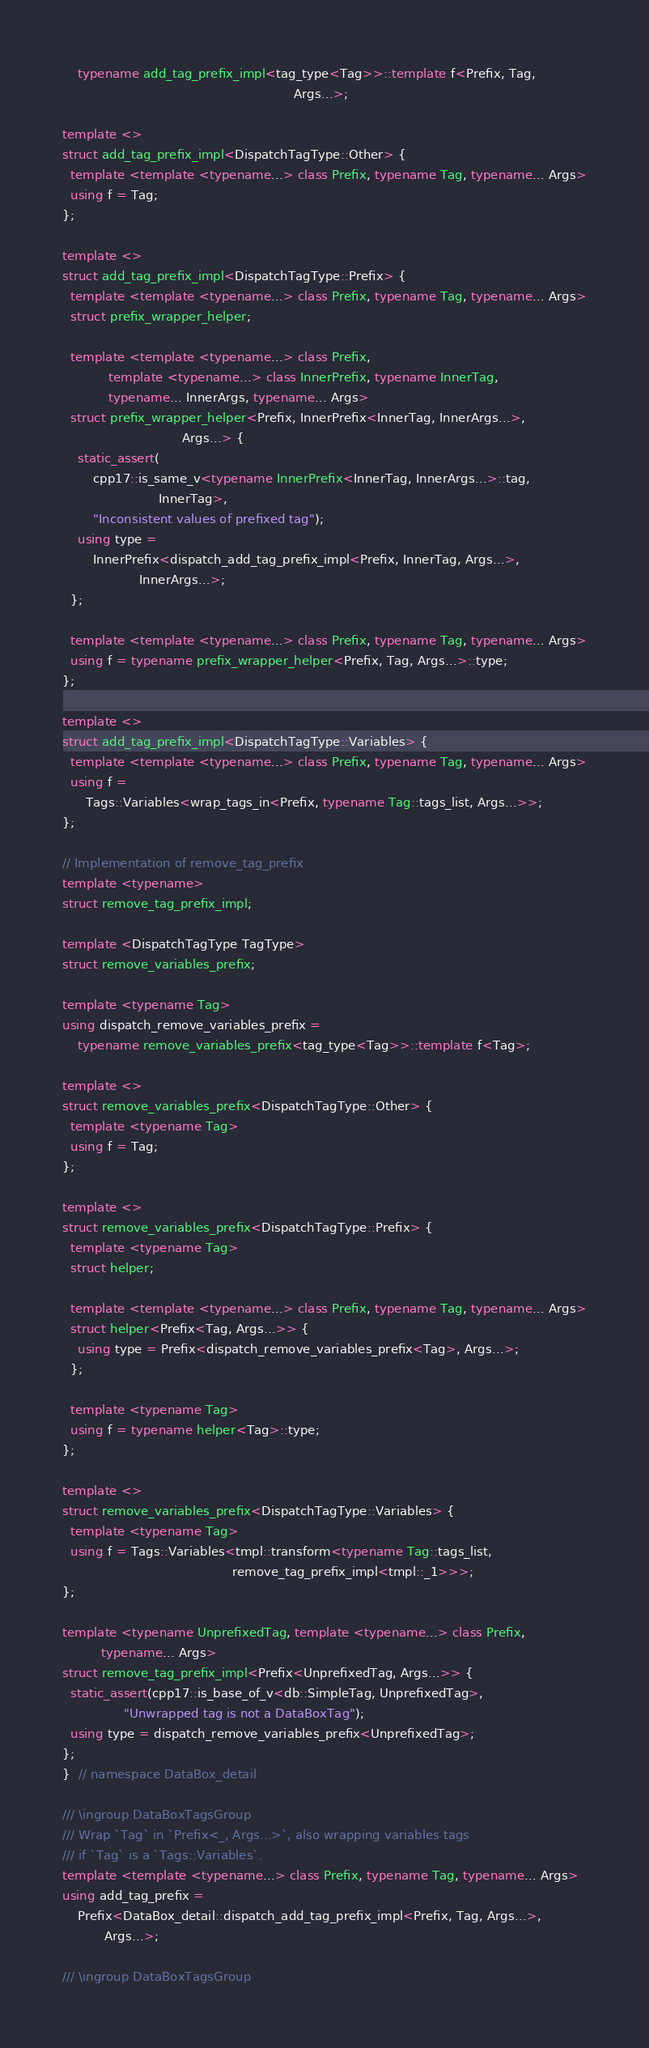<code> <loc_0><loc_0><loc_500><loc_500><_C++_>    typename add_tag_prefix_impl<tag_type<Tag>>::template f<Prefix, Tag,
                                                            Args...>;

template <>
struct add_tag_prefix_impl<DispatchTagType::Other> {
  template <template <typename...> class Prefix, typename Tag, typename... Args>
  using f = Tag;
};

template <>
struct add_tag_prefix_impl<DispatchTagType::Prefix> {
  template <template <typename...> class Prefix, typename Tag, typename... Args>
  struct prefix_wrapper_helper;

  template <template <typename...> class Prefix,
            template <typename...> class InnerPrefix, typename InnerTag,
            typename... InnerArgs, typename... Args>
  struct prefix_wrapper_helper<Prefix, InnerPrefix<InnerTag, InnerArgs...>,
                               Args...> {
    static_assert(
        cpp17::is_same_v<typename InnerPrefix<InnerTag, InnerArgs...>::tag,
                         InnerTag>,
        "Inconsistent values of prefixed tag");
    using type =
        InnerPrefix<dispatch_add_tag_prefix_impl<Prefix, InnerTag, Args...>,
                    InnerArgs...>;
  };

  template <template <typename...> class Prefix, typename Tag, typename... Args>
  using f = typename prefix_wrapper_helper<Prefix, Tag, Args...>::type;
};

template <>
struct add_tag_prefix_impl<DispatchTagType::Variables> {
  template <template <typename...> class Prefix, typename Tag, typename... Args>
  using f =
      Tags::Variables<wrap_tags_in<Prefix, typename Tag::tags_list, Args...>>;
};

// Implementation of remove_tag_prefix
template <typename>
struct remove_tag_prefix_impl;

template <DispatchTagType TagType>
struct remove_variables_prefix;

template <typename Tag>
using dispatch_remove_variables_prefix =
    typename remove_variables_prefix<tag_type<Tag>>::template f<Tag>;

template <>
struct remove_variables_prefix<DispatchTagType::Other> {
  template <typename Tag>
  using f = Tag;
};

template <>
struct remove_variables_prefix<DispatchTagType::Prefix> {
  template <typename Tag>
  struct helper;

  template <template <typename...> class Prefix, typename Tag, typename... Args>
  struct helper<Prefix<Tag, Args...>> {
    using type = Prefix<dispatch_remove_variables_prefix<Tag>, Args...>;
  };

  template <typename Tag>
  using f = typename helper<Tag>::type;
};

template <>
struct remove_variables_prefix<DispatchTagType::Variables> {
  template <typename Tag>
  using f = Tags::Variables<tmpl::transform<typename Tag::tags_list,
                                            remove_tag_prefix_impl<tmpl::_1>>>;
};

template <typename UnprefixedTag, template <typename...> class Prefix,
          typename... Args>
struct remove_tag_prefix_impl<Prefix<UnprefixedTag, Args...>> {
  static_assert(cpp17::is_base_of_v<db::SimpleTag, UnprefixedTag>,
                "Unwrapped tag is not a DataBoxTag");
  using type = dispatch_remove_variables_prefix<UnprefixedTag>;
};
}  // namespace DataBox_detail

/// \ingroup DataBoxTagsGroup
/// Wrap `Tag` in `Prefix<_, Args...>`, also wrapping variables tags
/// if `Tag` is a `Tags::Variables`.
template <template <typename...> class Prefix, typename Tag, typename... Args>
using add_tag_prefix =
    Prefix<DataBox_detail::dispatch_add_tag_prefix_impl<Prefix, Tag, Args...>,
           Args...>;

/// \ingroup DataBoxTagsGroup</code> 